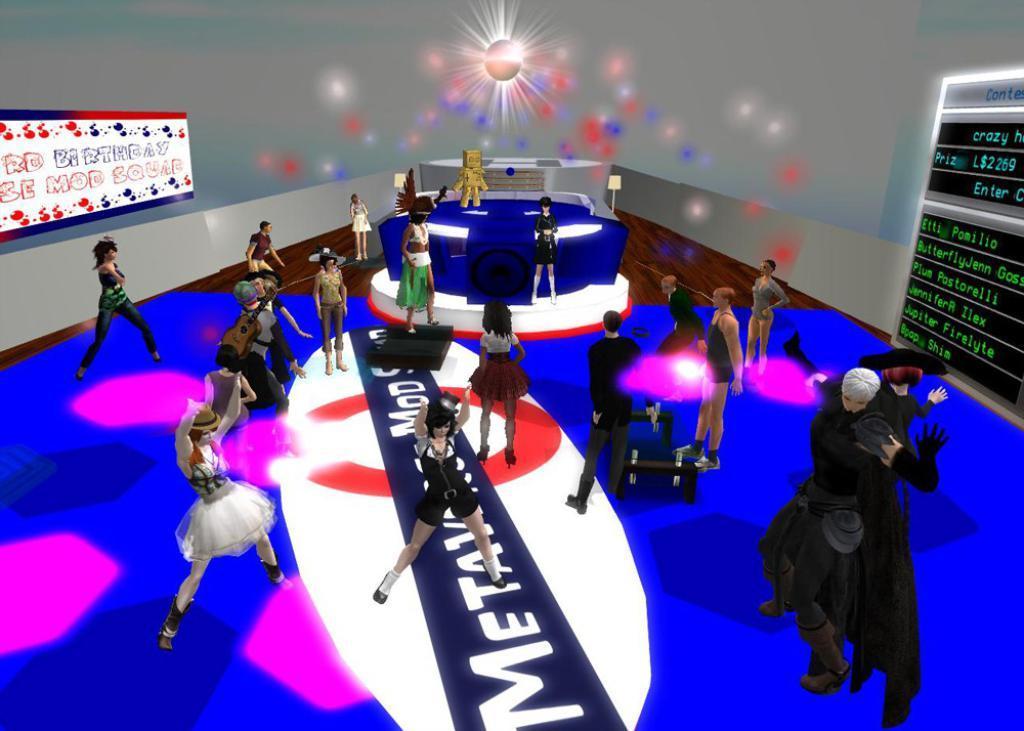Could you give a brief overview of what you see in this image? In this image we can see a few people dancing on the floor. Here we can see a person carrying the guitar. Here we can see an LCD screen on the right side. 